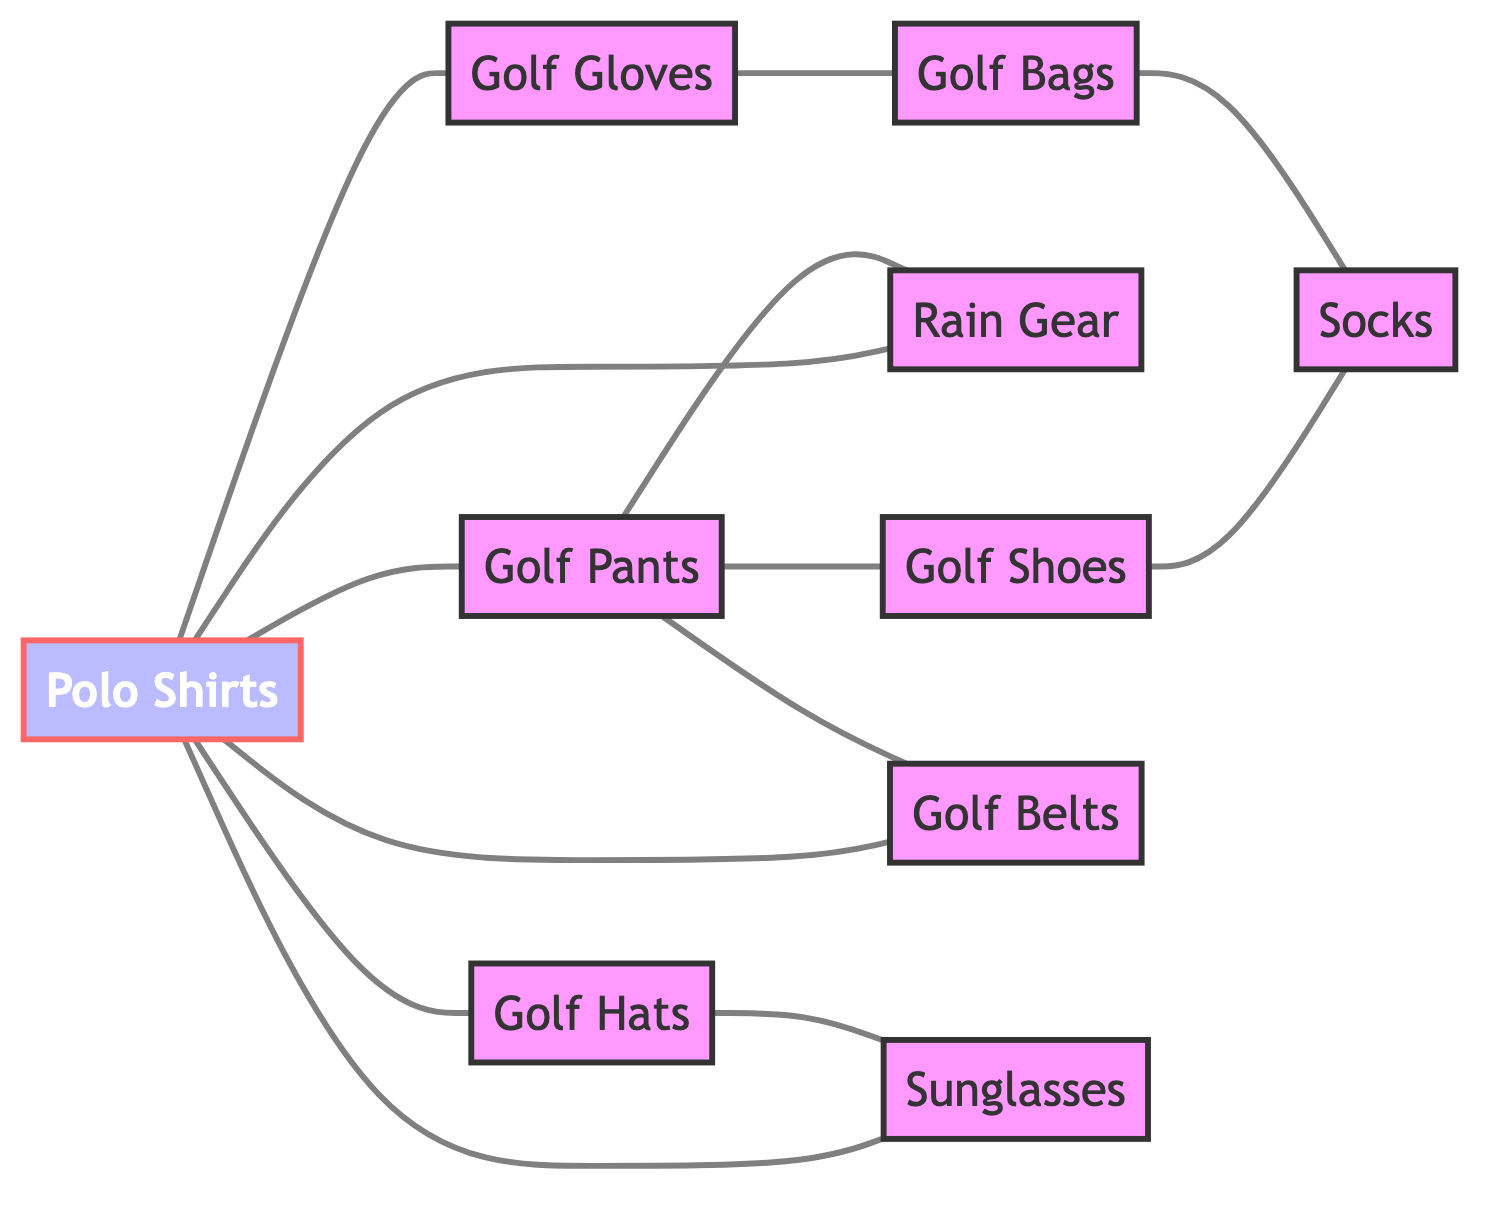What types of apparel are connected to Polo Shirts? The diagram shows edges connecting Polo Shirts to Golf Pants, Golf Belts, Golf Hats, Golf Gloves, Rain Gear, and Sunglasses. Therefore, these items are the types of apparel connected to Polo Shirts.
Answer: Golf Pants, Golf Belts, Golf Hats, Golf Gloves, Rain Gear, Sunglasses How many total nodes are in the graph? By counting the unique apparel and accessory items listed as nodes, there are 10 distinct nodes in total: Polo Shirts, Golf Pants, Golf Shoes, Golf Hats, Golf Gloves, Socks, Rain Gear, Golf Bags, Golf Belts, and Sunglasses.
Answer: 10 Which item is connected to Golf Pants and Golf Shoes? The edges indicate that Golf Pants is connected to Golf Shoes, and the only other item connected to Golf Pants is Golf Belts. Thus, Golf Belts is an item connected to both Golf Pants and Golf Shoes indirectly.
Answer: Golf Belts Which accessories are related to Golf Hats? The graph shows that Golf Hats is connected to Sunglasses and Polo Shirts. Therefore, these two accessories are related to Golf Hats according to the diagram.
Answer: Sunglasses, Polo Shirts How many edges does Golf Gloves have? Analyzing the edges connected to Golf Gloves, it relates to Golf Bags and Polo Shirts. As a result, Golf Gloves has 2 edges connecting it to other nodes.
Answer: 2 What is the only apparel connected to Socks? From the diagram, Socks is shown to be connected to Golf Shoes and Golf Bags only. Among these, the specific apparel connected directly is Golf Shoes.
Answer: Golf Shoes Which item has the most connections? By examining all the edges for each node, Polo Shirts has connections to Golf Pants, Golf Belts, Golf Hats, Golf Gloves, Rain Gear, and Sunglasses, totaling 6 connections. This is the highest number among all the items.
Answer: 6 Is Rain Gear connected to any accessories? The diagram do not show any edges linking Rain Gear to any accessory items; instead, it is directly connected to Polo Shirts and Golf Pants. Therefore, Rain Gear is not connected to any accessories.
Answer: No Which two types of apparel are directly connected but do not share any accessories? Examining the edges, Golf Shoes and Golf Bags are connected directly to each other through their connection with Socks. However, they do not have any direct edge to each other, only through Socks.
Answer: Golf Shoes, Golf Bags 